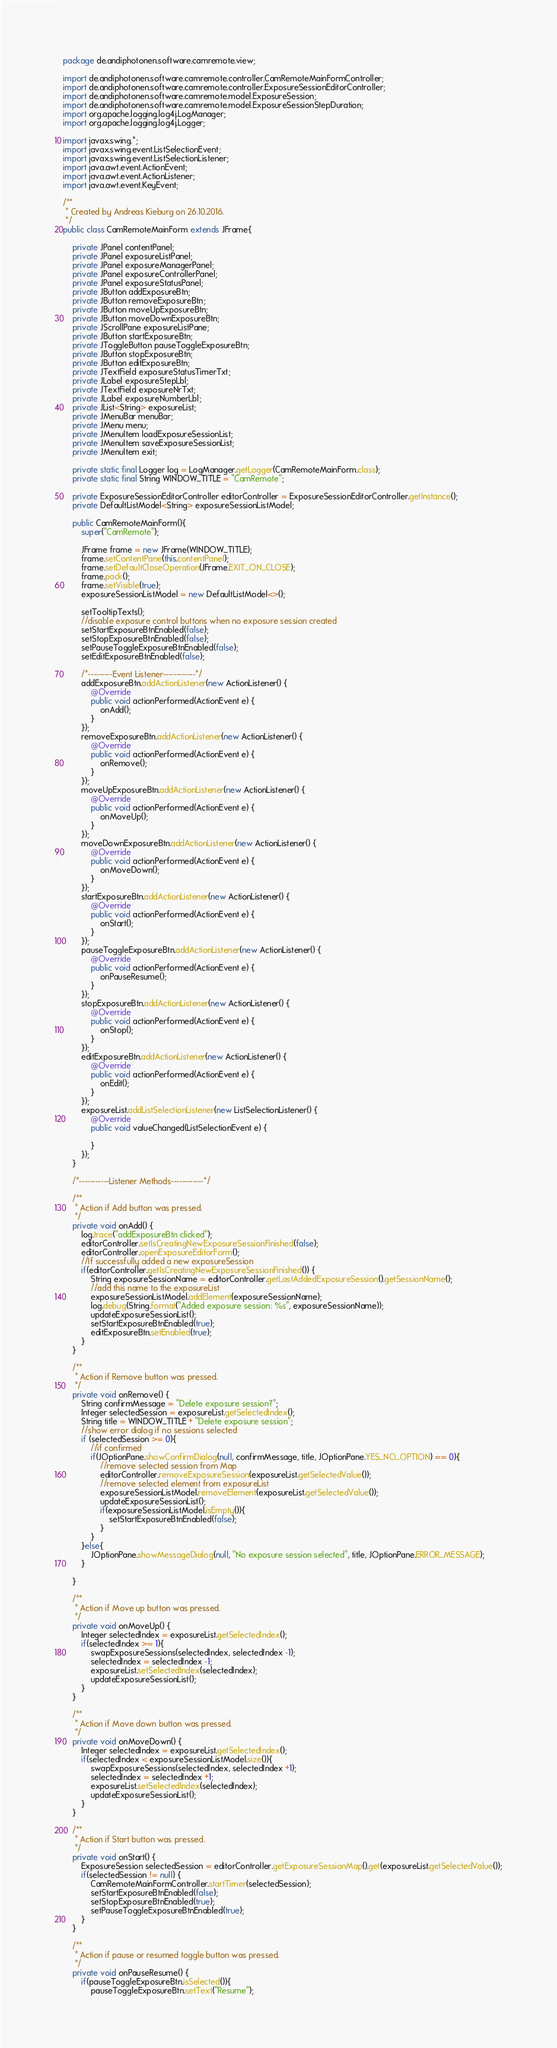Convert code to text. <code><loc_0><loc_0><loc_500><loc_500><_Java_>

package de.andiphotonen.software.camremote.view;

import de.andiphotonen.software.camremote.controller.CamRemoteMainFormController;
import de.andiphotonen.software.camremote.controller.ExposureSessionEditorController;
import de.andiphotonen.software.camremote.model.ExposureSession;
import de.andiphotonen.software.camremote.model.ExposureSessionStepDuration;
import org.apache.logging.log4j.LogManager;
import org.apache.logging.log4j.Logger;

import javax.swing.*;
import javax.swing.event.ListSelectionEvent;
import javax.swing.event.ListSelectionListener;
import java.awt.event.ActionEvent;
import java.awt.event.ActionListener;
import java.awt.event.KeyEvent;

/**
 * Created by Andreas Kieburg on 26.10.2016.
 */
public class CamRemoteMainForm extends JFrame{

    private JPanel contentPanel;
    private JPanel exposureListPanel;
    private JPanel exposureManagerPanel;
    private JPanel exposureControllerPanel;
    private JPanel exposureStatusPanel;
    private JButton addExposureBtn;
    private JButton removeExposureBtn;
    private JButton moveUpExposureBtn;
    private JButton moveDownExposureBtn;
    private JScrollPane exposureListPane;
    private JButton startExposureBtn;
    private JToggleButton pauseToggleExposureBtn;
    private JButton stopExposureBtn;
    private JButton editExposureBtn;
    private JTextField exposureStatusTimerTxt;
    private JLabel exposureStepLbl;
    private JTextField exposureNrTxt;
    private JLabel exposureNumberLbl;
    private JList<String> exposureList;
    private JMenuBar menuBar;
    private JMenu menu;
    private JMenuItem loadExposureSessionList;
    private JMenuItem saveExposureSessionList;
    private JMenuItem exit;

    private static final Logger log = LogManager.getLogger(CamRemoteMainForm.class);
    private static final String WINDOW_TITLE = "CamRemote";

    private ExposureSessionEditorController editorController = ExposureSessionEditorController.getInstance();
    private DefaultListModel<String> exposureSessionListModel;

    public CamRemoteMainForm(){
        super("CamRemote");

        JFrame frame = new JFrame(WINDOW_TITLE);
        frame.setContentPane(this.contentPanel);
        frame.setDefaultCloseOperation(JFrame.EXIT_ON_CLOSE);
        frame.pack();
        frame.setVisible(true);
        exposureSessionListModel = new DefaultListModel<>();

        setTooltipTexts();
        //disable exposure control buttons when no exposure session created
        setStartExposureBtnEnabled(false);
        setStopExposureBtnEnabled(false);
        setPauseToggleExposureBtnEnabled(false);
        setEditExposureBtnEnabled(false);

        /*---------Event Listener------------*/
        addExposureBtn.addActionListener(new ActionListener() {
            @Override
            public void actionPerformed(ActionEvent e) {
                onAdd();
            }
        });
        removeExposureBtn.addActionListener(new ActionListener() {
            @Override
            public void actionPerformed(ActionEvent e) {
                onRemove();
            }
        });
        moveUpExposureBtn.addActionListener(new ActionListener() {
            @Override
            public void actionPerformed(ActionEvent e) {
                onMoveUp();
            }
        });
        moveDownExposureBtn.addActionListener(new ActionListener() {
            @Override
            public void actionPerformed(ActionEvent e) {
                onMoveDown();
            }
        });
        startExposureBtn.addActionListener(new ActionListener() {
            @Override
            public void actionPerformed(ActionEvent e) {
                onStart();
            }
        });
        pauseToggleExposureBtn.addActionListener(new ActionListener() {
            @Override
            public void actionPerformed(ActionEvent e) {
                onPauseResume();
            }
        });
        stopExposureBtn.addActionListener(new ActionListener() {
            @Override
            public void actionPerformed(ActionEvent e) {
                onStop();
            }
        });
        editExposureBtn.addActionListener(new ActionListener() {
            @Override
            public void actionPerformed(ActionEvent e) {
                onEdit();
            }
        });
        exposureList.addListSelectionListener(new ListSelectionListener() {
            @Override
            public void valueChanged(ListSelectionEvent e) {

            }
        });
    }

    /*-----------Listener Methods------------*/

    /**
     * Action if Add button was pressed.
     */
    private void onAdd() {
        log.trace("addExposureBtn clicked");
        editorController.setIsCreatingNewExposureSessionFinished(false);
        editorController.openExposureEditorForm();
        //If successfully added a new exposureSession
        if(editorController.getIsCreatingNewExposureSessionFinished()) {
            String exposureSessionName = editorController.getLastAddedExposureSession().getSessionName();
            //add this name to the exposureList
            exposureSessionListModel.addElement(exposureSessionName);
            log.debug(String.format("Added exposure session: %s", exposureSessionName));
            updateExposureSessionList();
            setStartExposureBtnEnabled(true);
            editExposureBtn.setEnabled(true);
        }
    }

    /**
     * Action if Remove button was pressed.
     */
    private void onRemove() {
        String confirmMessage = "Delete exposure session?";
        Integer selectedSession = exposureList.getSelectedIndex();
        String title = WINDOW_TITLE + "Delete exposure session";
        //show error dialog if no sessions selected
        if (selectedSession >= 0){
            //if confirmed
            if(JOptionPane.showConfirmDialog(null, confirmMessage, title, JOptionPane.YES_NO_OPTION) == 0){
                //remove selected session from Map
                editorController.removeExposureSession(exposureList.getSelectedValue());
                //remove selected element from exposureList
                exposureSessionListModel.removeElement(exposureList.getSelectedValue());
                updateExposureSessionList();
                if(exposureSessionListModel.isEmpty()){
                    setStartExposureBtnEnabled(false);
                }
            }
        }else{
            JOptionPane.showMessageDialog(null, "No exposure session selected", title, JOptionPane.ERROR_MESSAGE);
        }

    }

    /**
     * Action if Move up button was pressed.
     */
    private void onMoveUp() {
        Integer selectedIndex = exposureList.getSelectedIndex();
        if(selectedIndex >= 1){
            swapExposureSessions(selectedIndex, selectedIndex -1);
            selectedIndex = selectedIndex -1;
            exposureList.setSelectedIndex(selectedIndex);
            updateExposureSessionList();
        }
    }

    /**
     * Action if Move down button was pressed.
     */
    private void onMoveDown() {
        Integer selectedIndex = exposureList.getSelectedIndex();
        if(selectedIndex < exposureSessionListModel.size()){
            swapExposureSessions(selectedIndex, selectedIndex +1);
            selectedIndex = selectedIndex +1;
            exposureList.setSelectedIndex(selectedIndex);
            updateExposureSessionList();
        }
    }

    /**
     * Action if Start button was pressed.
     */
    private void onStart() {
        ExposureSession selectedSession = editorController.getExposureSessionMap().get(exposureList.getSelectedValue());
        if(selectedSession != null) {
            CamRemoteMainFormController.startTimer(selectedSession);
            setStartExposureBtnEnabled(false);
            setStopExposureBtnEnabled(true);
            setPauseToggleExposureBtnEnabled(true);
        }
    }

    /**
     * Action if pause or resumed toggle button was pressed.
     */
    private void onPauseResume() {
        if(pauseToggleExposureBtn.isSelected()){
            pauseToggleExposureBtn.setText("Resume");</code> 